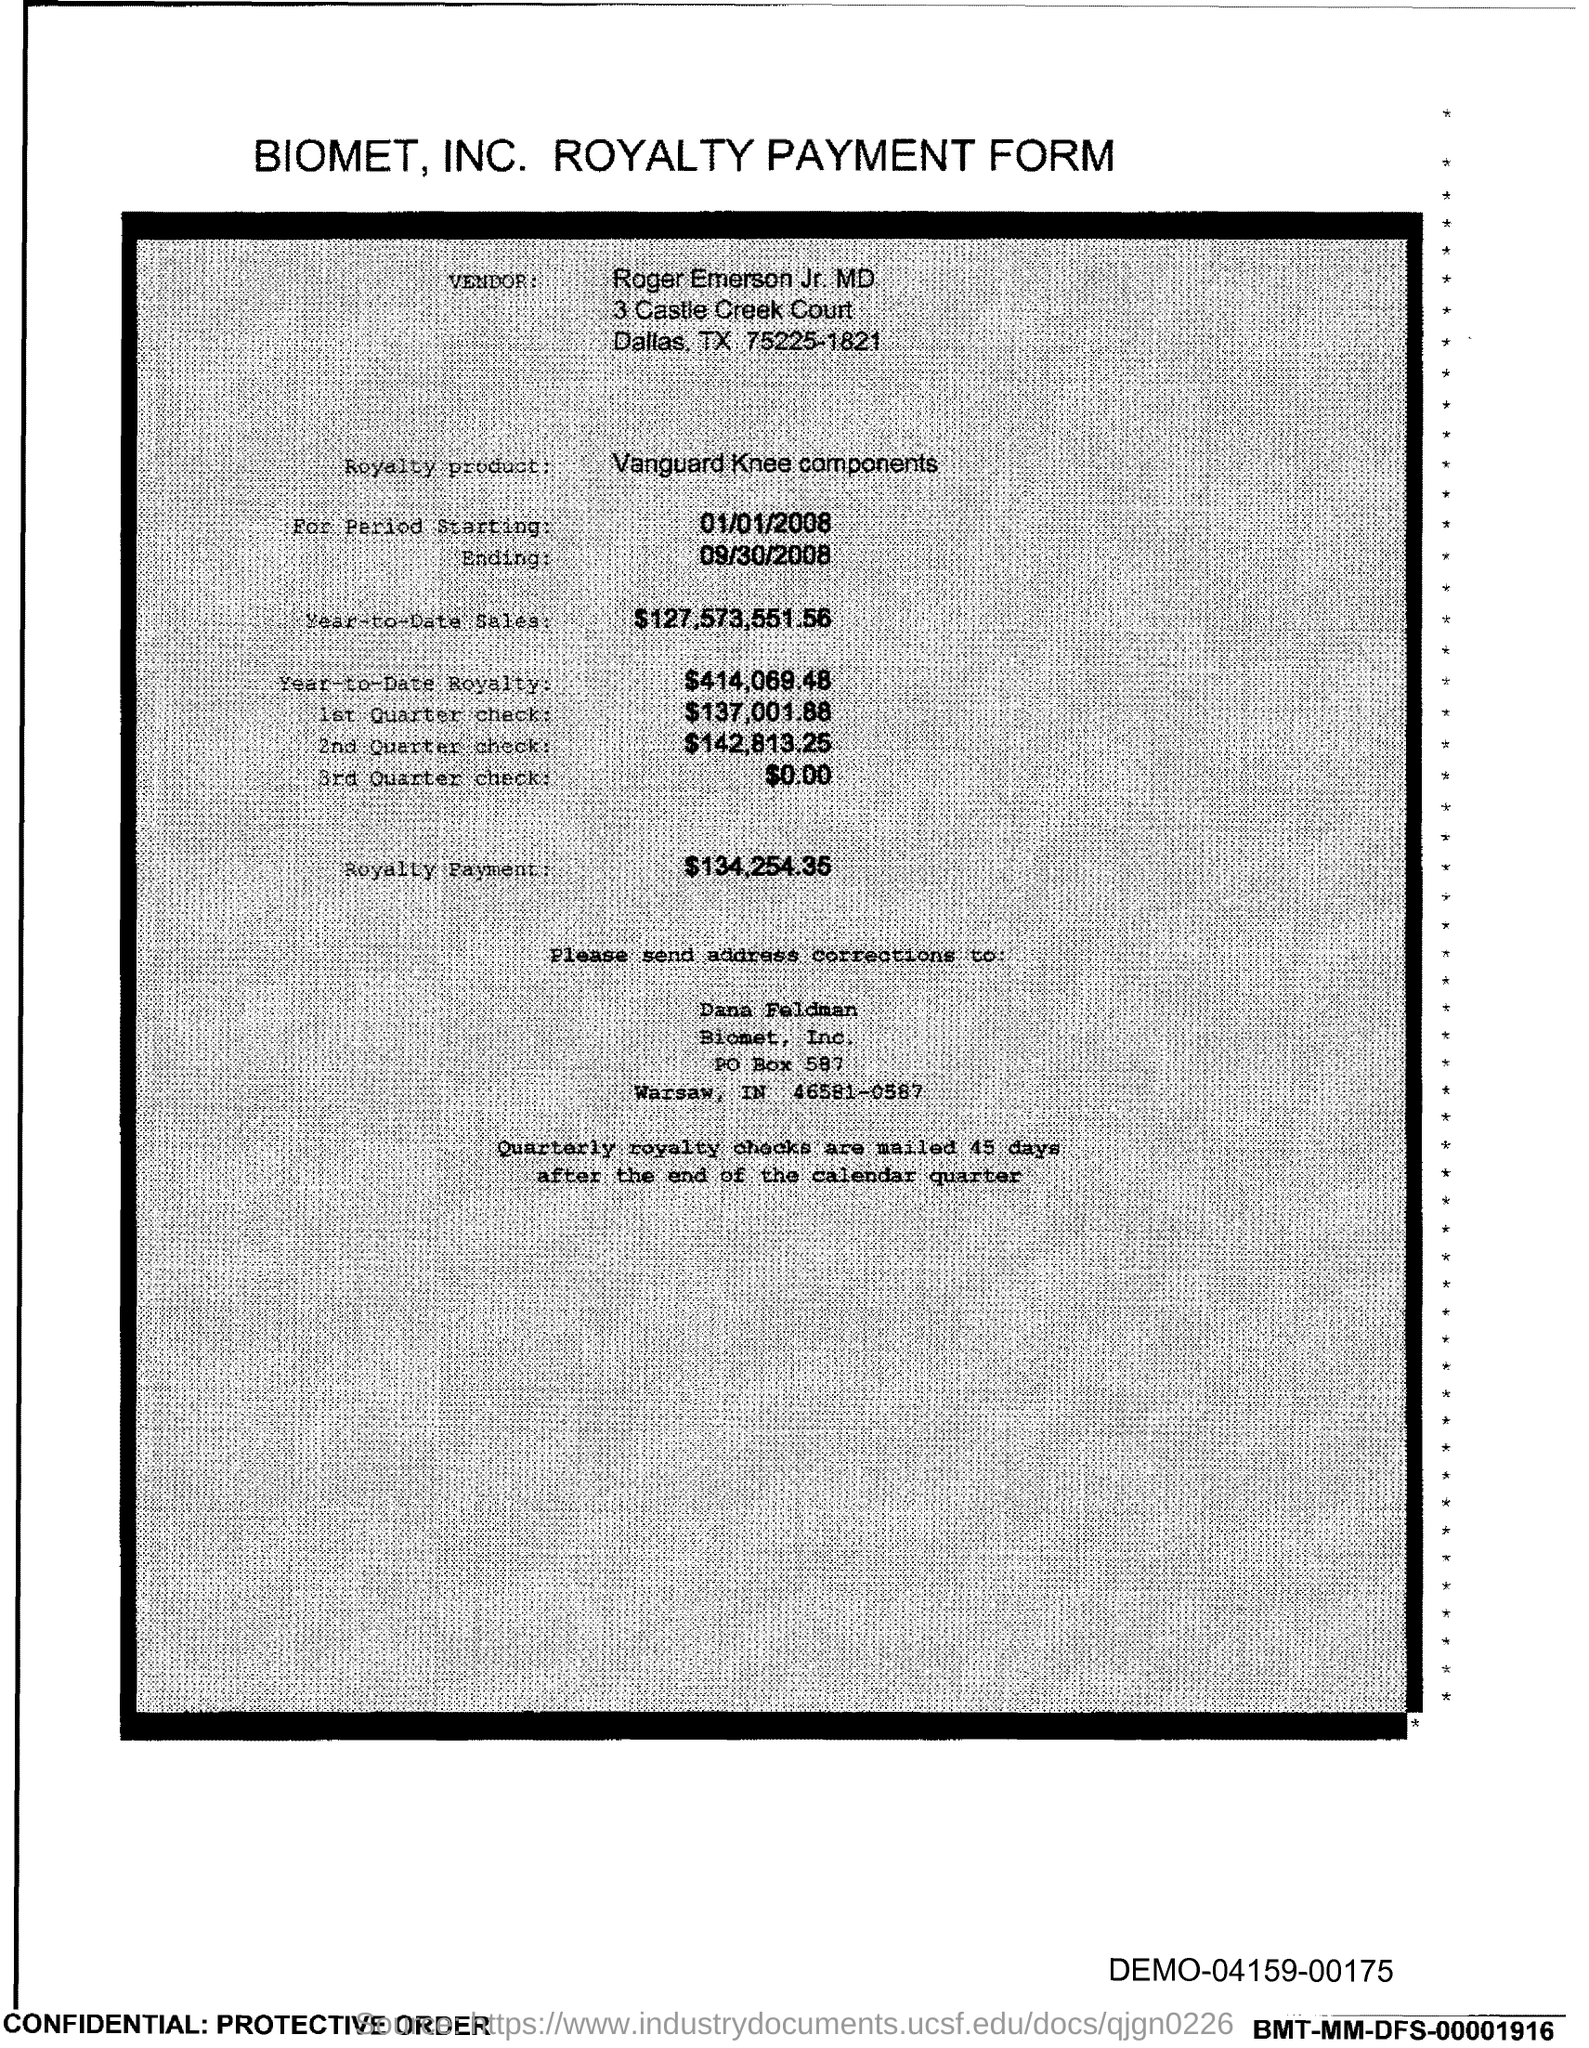What is the PO Box Number mentioned in the document?
Your response must be concise. 587. 